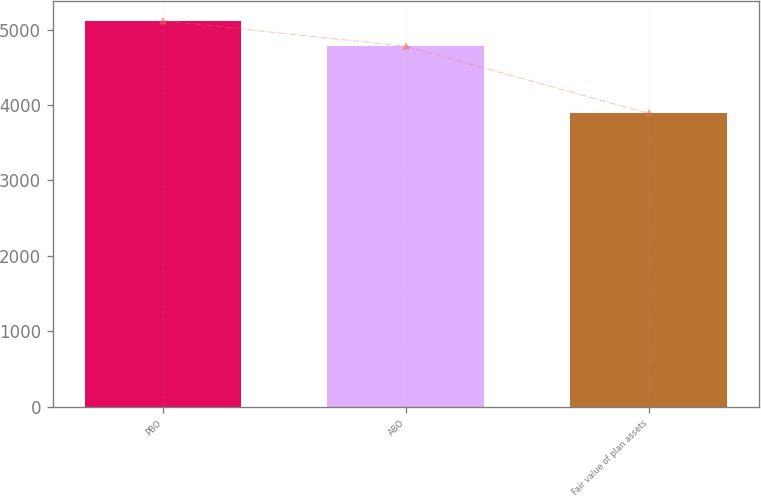Convert chart to OTSL. <chart><loc_0><loc_0><loc_500><loc_500><bar_chart><fcel>PBO<fcel>ABO<fcel>Fair value of plan assets<nl><fcel>5120.3<fcel>4780.4<fcel>3890<nl></chart> 